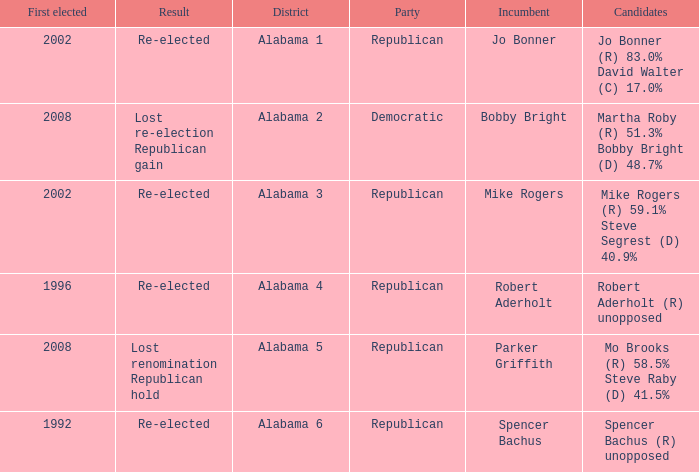Name the result for first elected being 1992 Re-elected. 